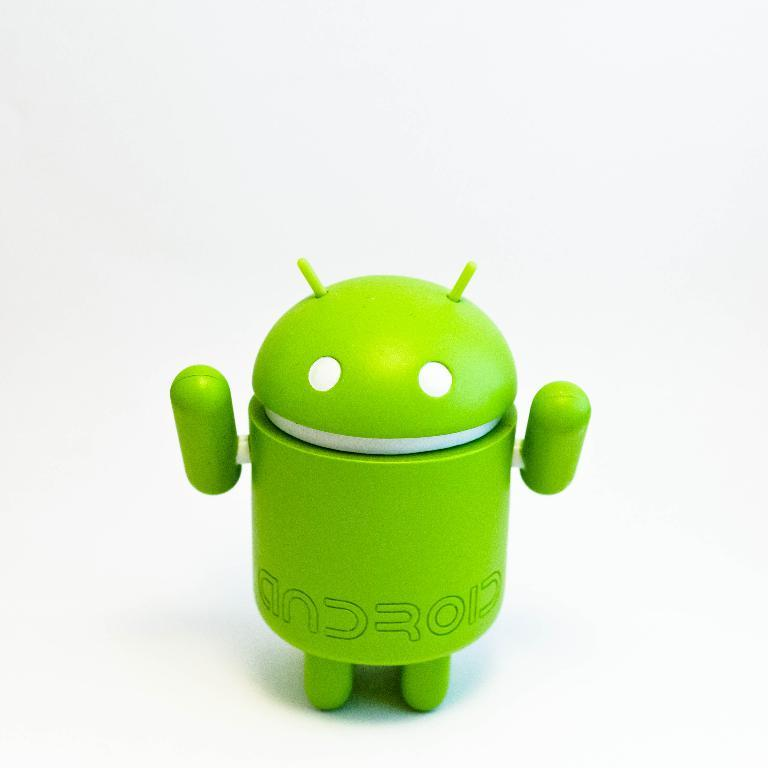<image>
Describe the image concisely. A lime green robot made for Andriod devices. 